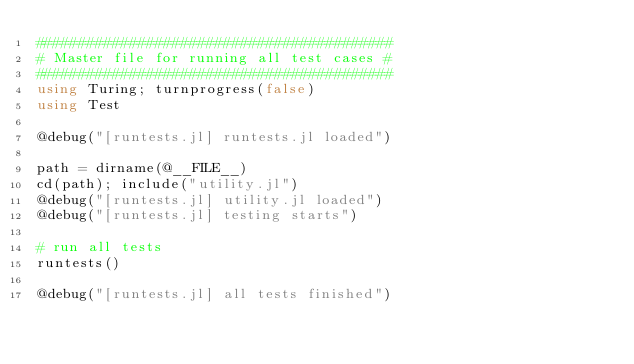Convert code to text. <code><loc_0><loc_0><loc_500><loc_500><_Julia_>##########################################
# Master file for running all test cases #
##########################################
using Turing; turnprogress(false)
using Test

@debug("[runtests.jl] runtests.jl loaded")

path = dirname(@__FILE__)
cd(path); include("utility.jl")
@debug("[runtests.jl] utility.jl loaded")
@debug("[runtests.jl] testing starts")

# run all tests
runtests()

@debug("[runtests.jl] all tests finished")
</code> 